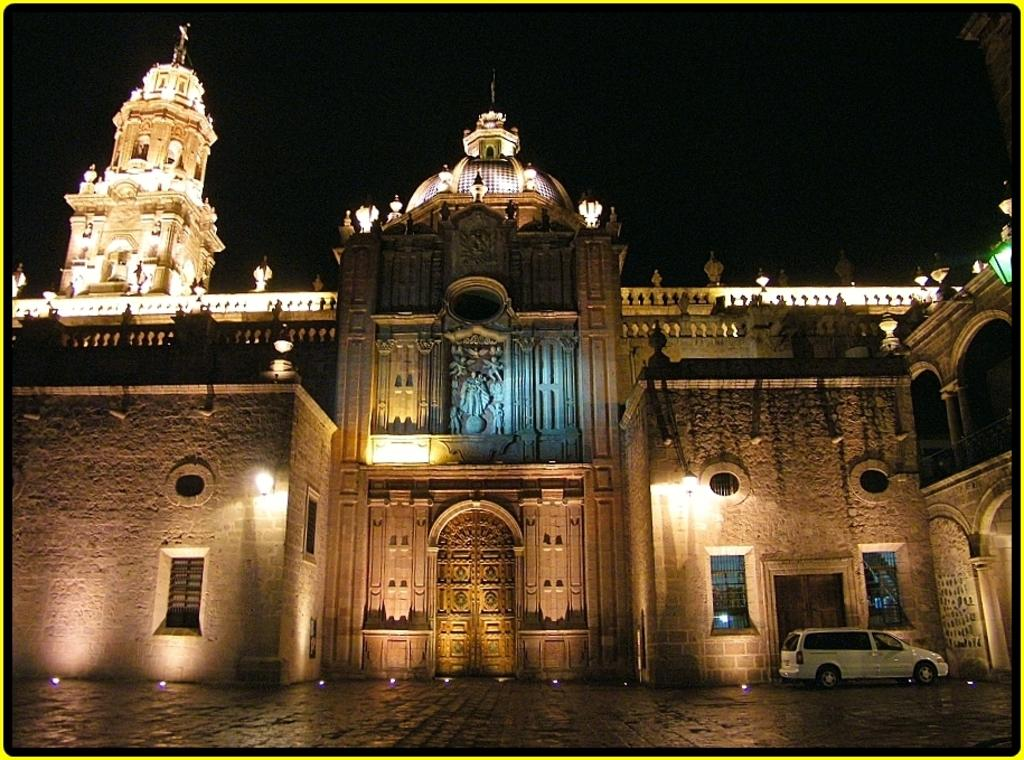What structure is the main subject of the image? There is a building in the image. What can be seen on the walls of the building? There are lights on the walls of the building. What is located on the top of the building? There are lights on the top of the building. What type of vehicle is on the right side of the image? There is a white-colored car on the right side of the image. What type of dress is the teacher wearing in the image? There is no teacher or dress present in the image; it features a building with lights and a white-colored car. 